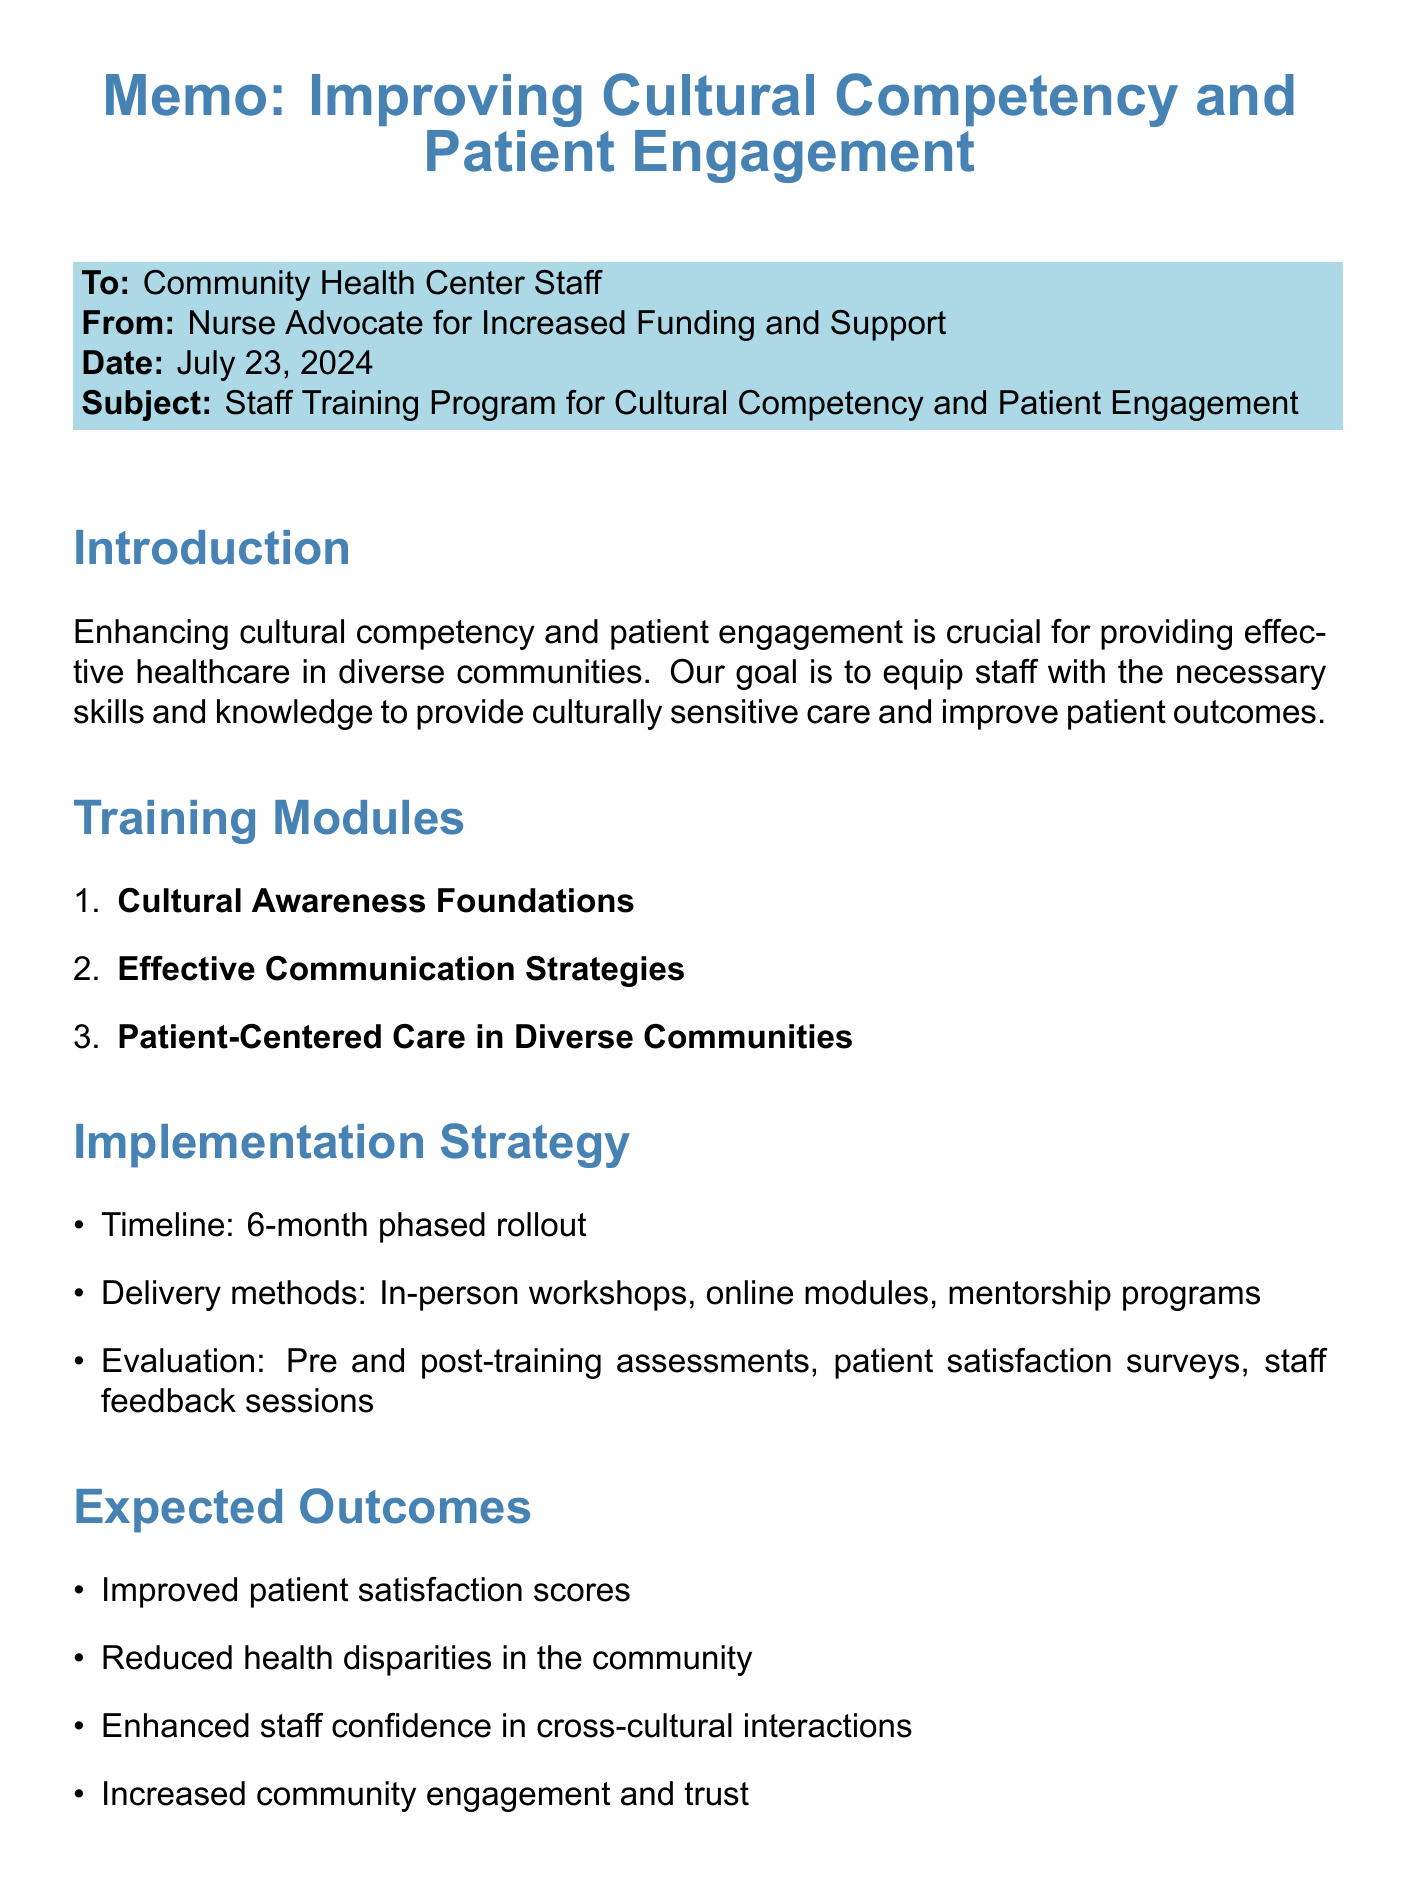what is the title of the memo? The title of the memo is found at the beginning of the document.
Answer: Improving Cultural Competency and Patient Engagement in Community Health Settings how many training modules are outlined in the document? The number of training modules can be counted in the section detailing the training modules.
Answer: 3 what is the goal of the staff training program? The goal is mentioned in the introduction section of the memo.
Answer: To equip staff with the necessary skills and knowledge to provide culturally sensitive care and improve patient outcomes what is one of the expected outcomes mentioned? This is found in the section that lists the expected outcomes.
Answer: Improved patient satisfaction scores what resources are mentioned in the document? The resources are listed in a specific section of the memo.
Answer: National CLAS Standards, Think Cultural Health, Health Resources and Services Administration (HRSA) Culture, Language, and Health Literacy Resources what is the timeline for the implementation strategy? The timeline is stated in the implementation strategy section.
Answer: 6-month phased rollout what is one funding source mentioned? The potential sources are listed in the funding considerations section of the memo.
Answer: HRSA grants for health center program what type of activities are included in the training modules? The activities are detailed under each training module section.
Answer: Interactive case studies, Role-playing exercises, Community health worker shadowing what should the next step be after investing in training? The next steps are outlined in the conclusion section of the memo.
Answer: Secure funding and resources 